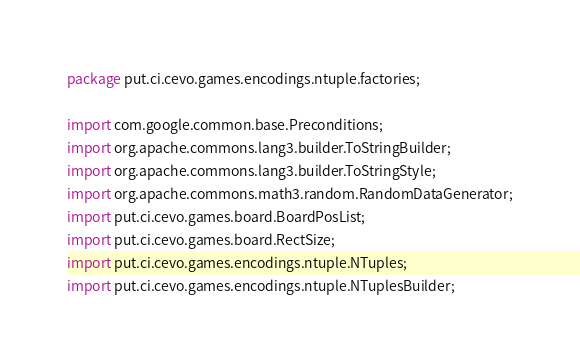<code> <loc_0><loc_0><loc_500><loc_500><_Java_>package put.ci.cevo.games.encodings.ntuple.factories;

import com.google.common.base.Preconditions;
import org.apache.commons.lang3.builder.ToStringBuilder;
import org.apache.commons.lang3.builder.ToStringStyle;
import org.apache.commons.math3.random.RandomDataGenerator;
import put.ci.cevo.games.board.BoardPosList;
import put.ci.cevo.games.board.RectSize;
import put.ci.cevo.games.encodings.ntuple.NTuples;
import put.ci.cevo.games.encodings.ntuple.NTuplesBuilder;</code> 